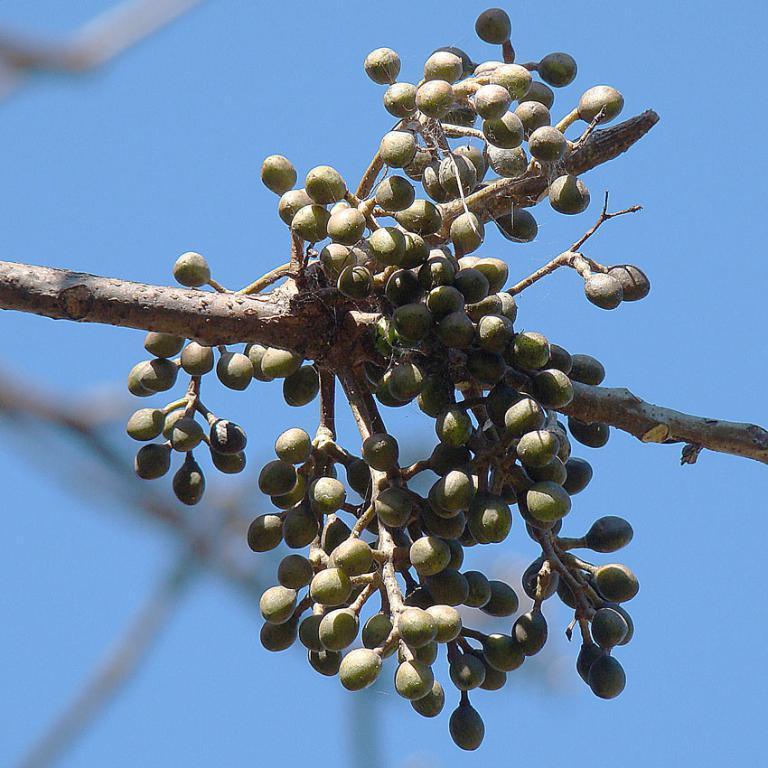Could you give a brief overview of what you see in this image? This picture is clicked outside. In the center we can see some food items seems to be the fruits hanging on the branch of a tree. In the background we can see the sky and some other objects. 